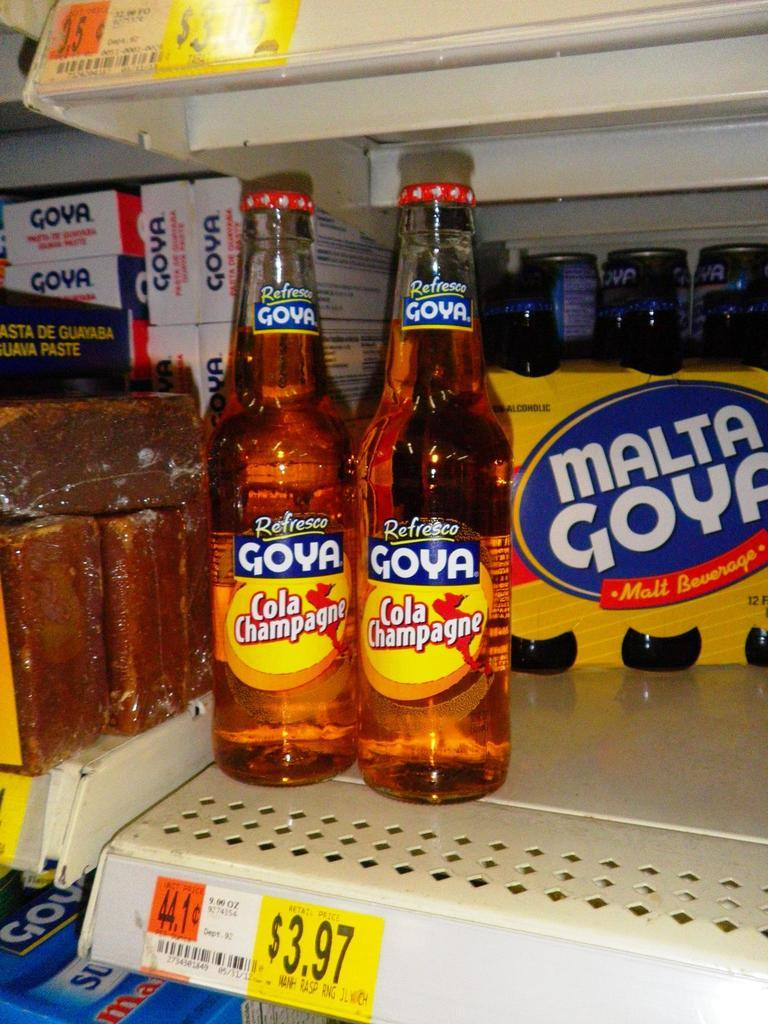<image>
Describe the image concisely. Two cola champagne bottles made by Refresco Goya sit at the store. 